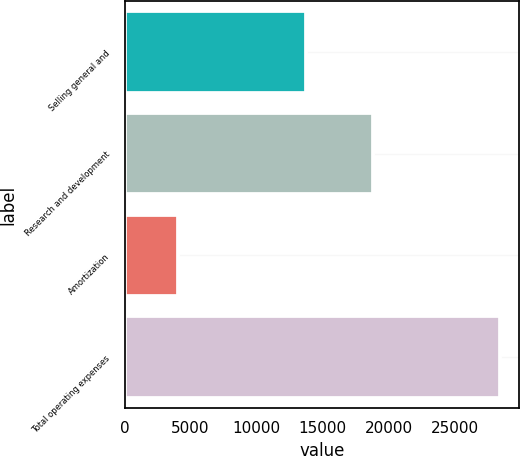Convert chart to OTSL. <chart><loc_0><loc_0><loc_500><loc_500><bar_chart><fcel>Selling general and<fcel>Research and development<fcel>Amortization<fcel>Total operating expenses<nl><fcel>13729<fcel>18811<fcel>4084<fcel>28456<nl></chart> 